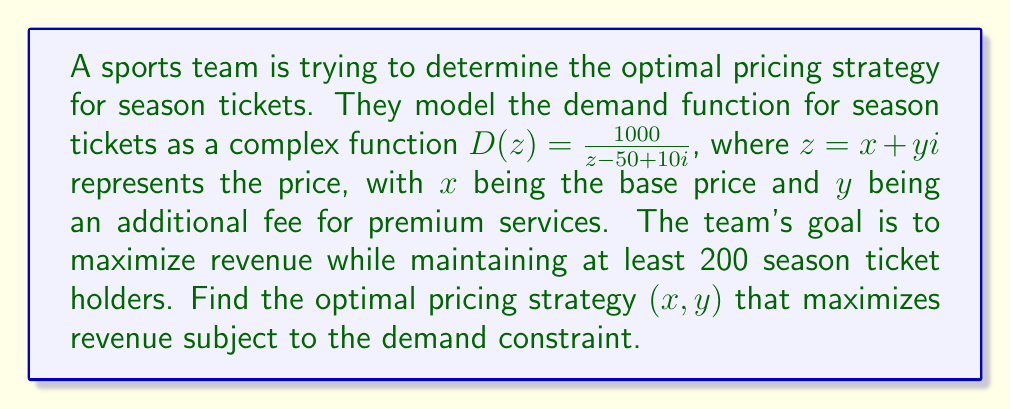Help me with this question. To solve this problem, we'll follow these steps:

1) The revenue function $R(z)$ is given by the product of price and demand:
   $$R(z) = z \cdot D(z) = z \cdot \frac{1000}{z - 50 + 10i}$$

2) We need to find the modulus of $D(z)$ to ensure it's at least 200:
   $$|D(z)| = \left|\frac{1000}{z - 50 + 10i}\right| \geq 200$$

3) This implies:
   $$\frac{1000}{|z - 50 + 10i|} \geq 200$$
   $$|z - 50 + 10i| \leq 5$$

4) This describes a circle in the complex plane with center at $(50, -10)$ and radius 5.

5) To maximize revenue, we need to find the point on this circle that gives the largest value of $|R(z)|$.

6) The maximum of $|R(z)|$ occurs when $z$ is as far as possible from the point $50 - 10i$, which is the point on the circle farthest from the center.

7) This point is at $(55, -10)$, or $z = 55 - 10i$.

8) To verify, we can calculate the revenue:
   $$R(55 - 10i) = (55 - 10i) \cdot \frac{1000}{5} = 11000 - 2000i$$

9) The magnitude of this revenue is:
   $$|R(55 - 10i)| = \sqrt{11000^2 + 2000^2} = \sqrt{125,000,000} = 11180.34$$

Therefore, the optimal pricing strategy is a base price of $55 with a premium fee of $10.
Answer: The optimal pricing strategy is $(x, y) = (55, 10)$, meaning a base price of $55 and a premium fee of $10. This strategy yields a maximum revenue of $11,180.34. 